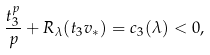<formula> <loc_0><loc_0><loc_500><loc_500>\frac { t _ { 3 } ^ { p } } p + R _ { \lambda } ( t _ { 3 } v _ { * } ) = c _ { 3 } ( \lambda ) < 0 ,</formula> 